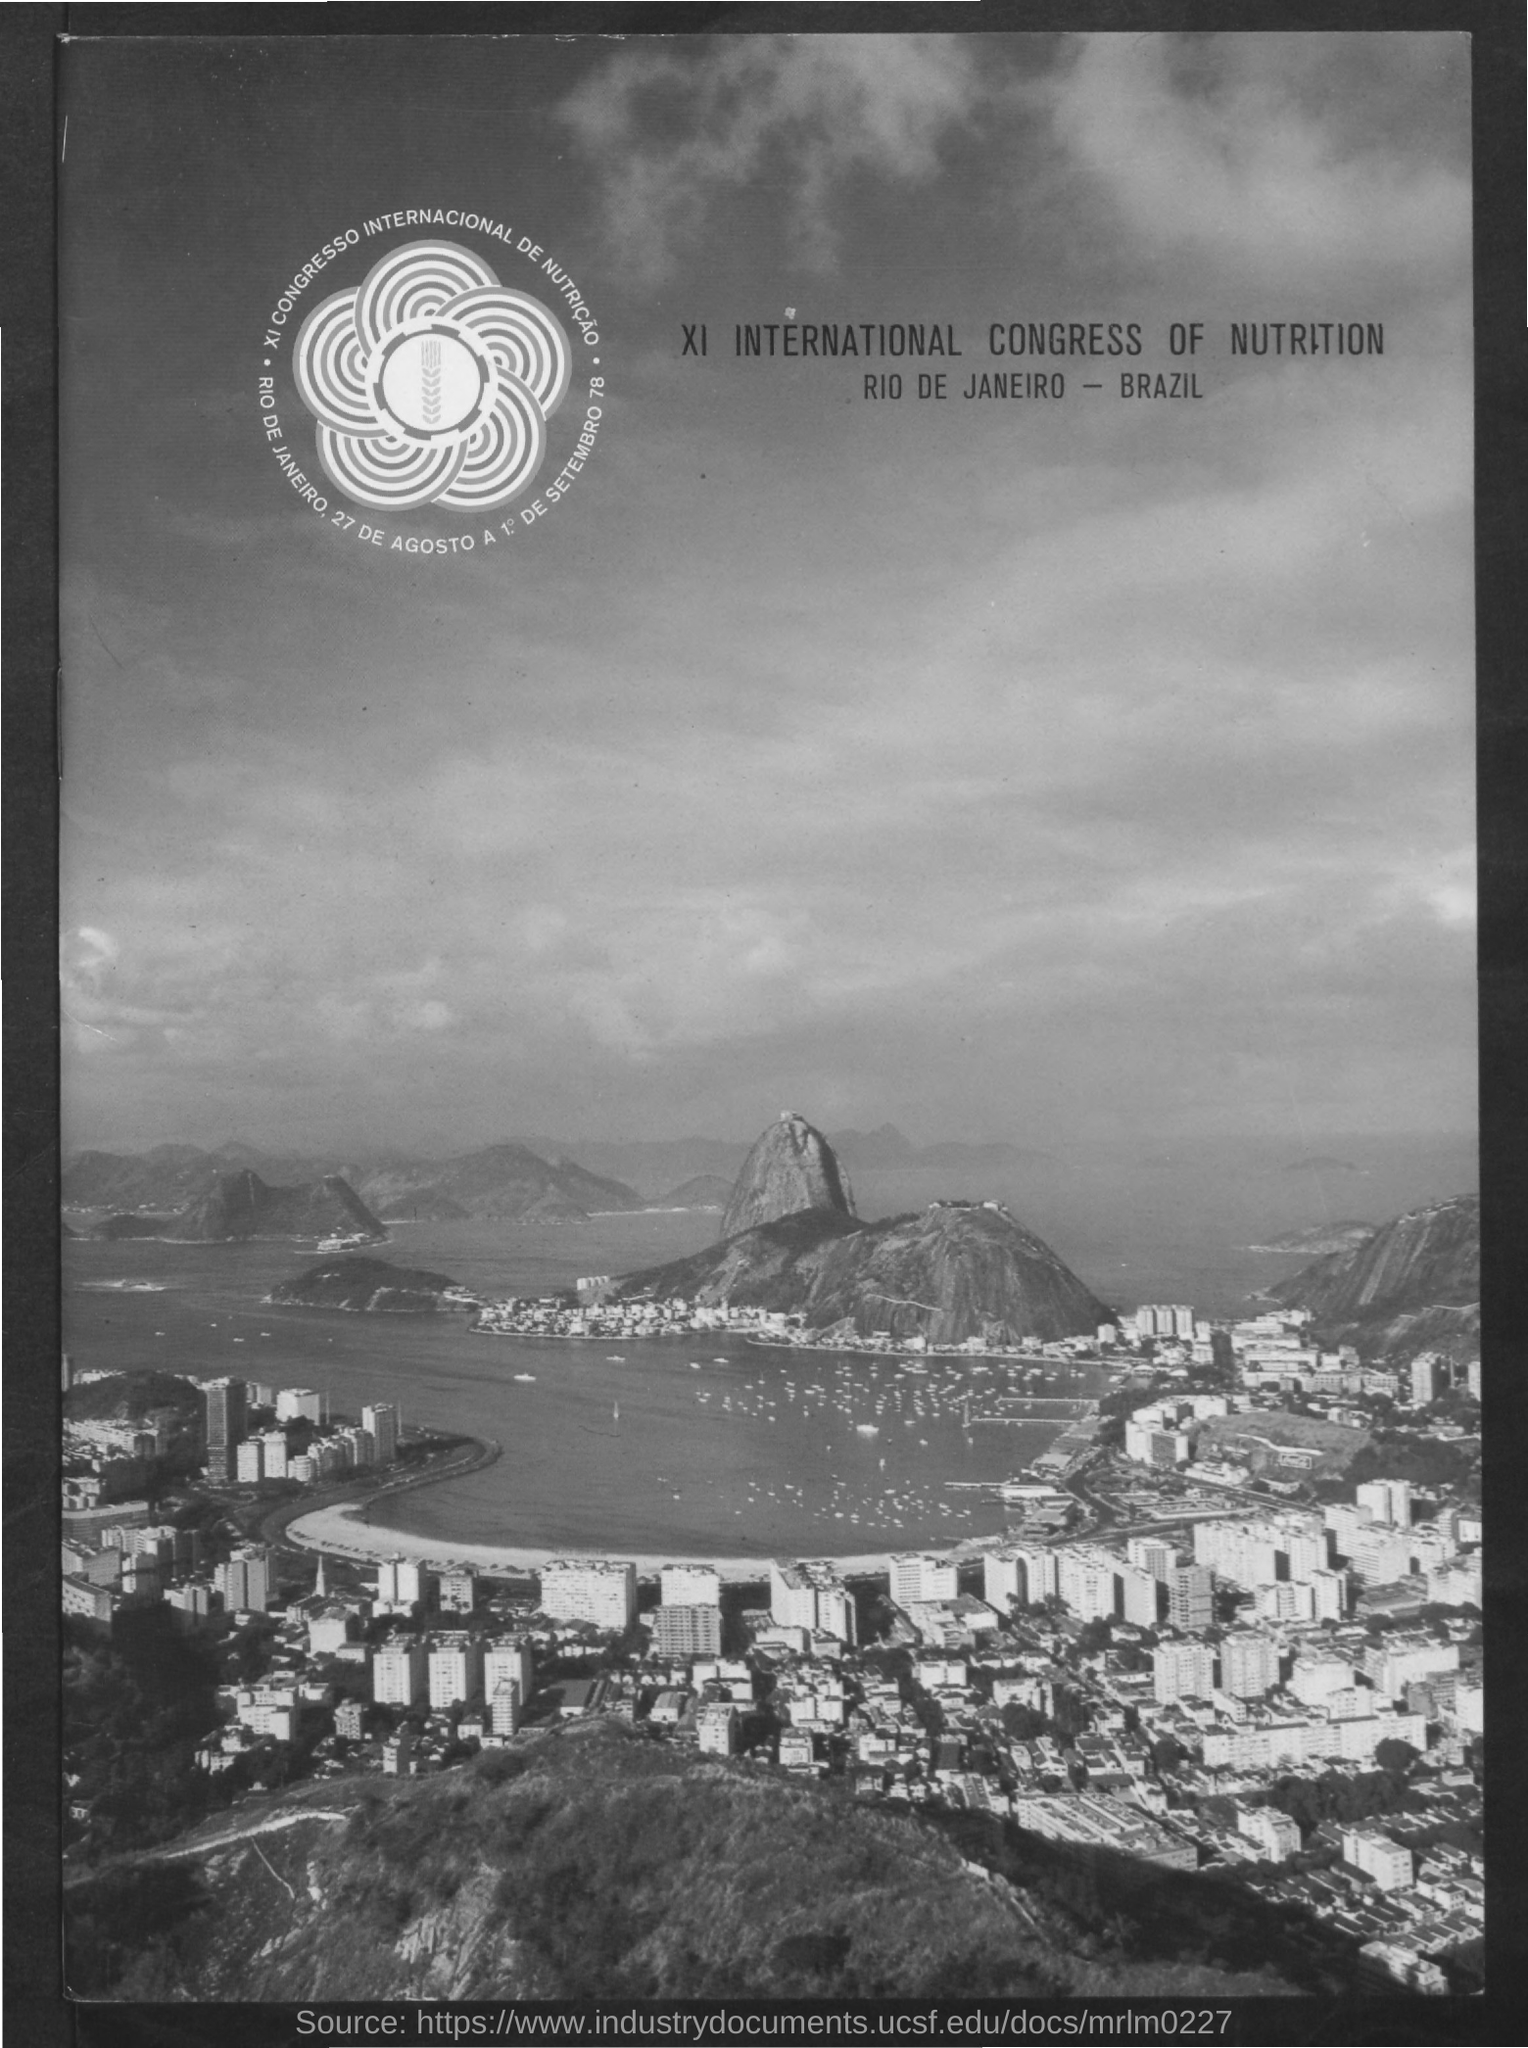Mention a couple of crucial points in this snapshot. The name of the program is the XI International Congress of Nutrition. The location of the upcoming congress has been announced to be Rio de Janeiro in Brazil. 